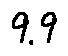Convert formula to latex. <formula><loc_0><loc_0><loc_500><loc_500>9 . 9</formula> 